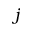Convert formula to latex. <formula><loc_0><loc_0><loc_500><loc_500>j</formula> 